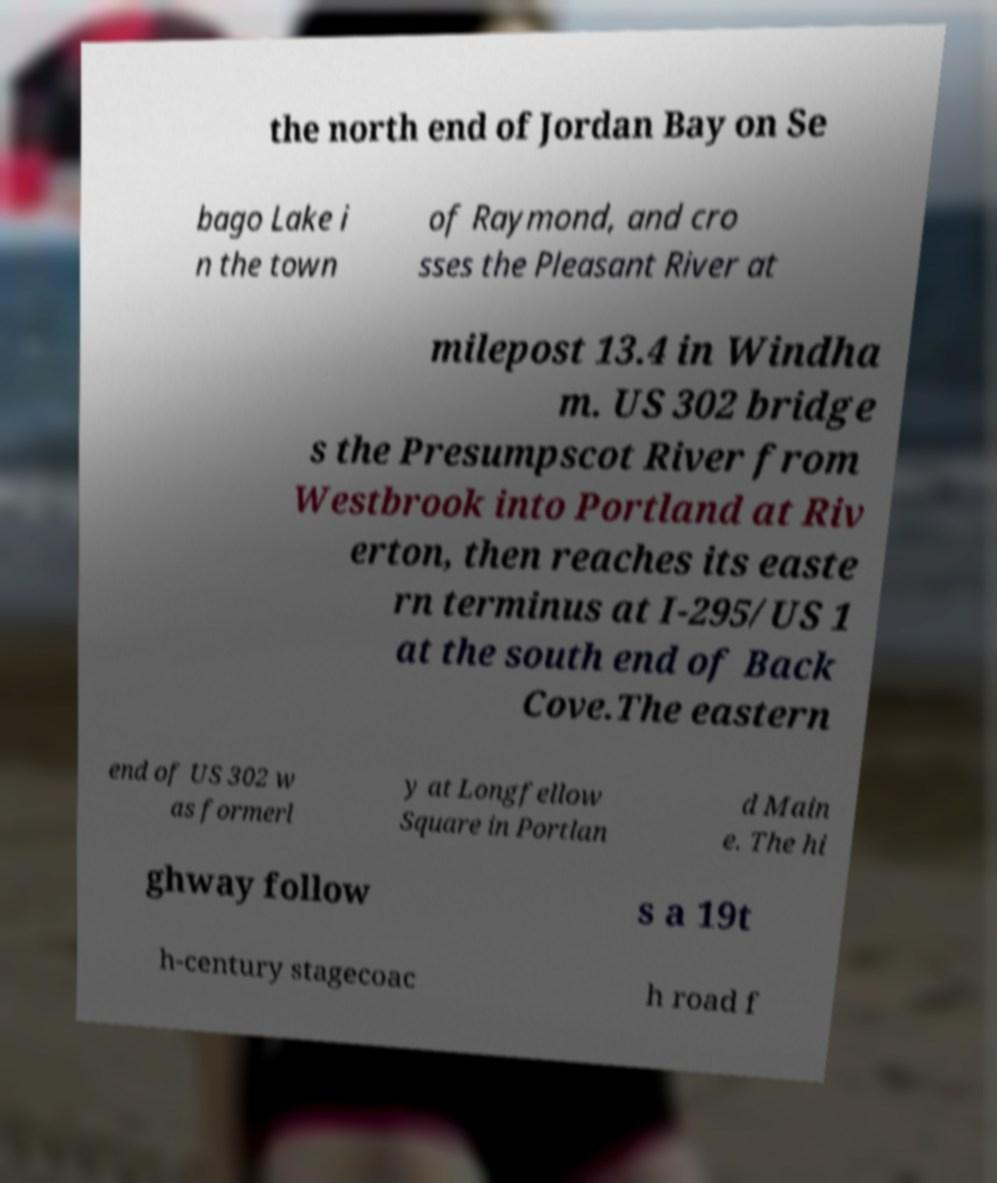There's text embedded in this image that I need extracted. Can you transcribe it verbatim? the north end of Jordan Bay on Se bago Lake i n the town of Raymond, and cro sses the Pleasant River at milepost 13.4 in Windha m. US 302 bridge s the Presumpscot River from Westbrook into Portland at Riv erton, then reaches its easte rn terminus at I-295/US 1 at the south end of Back Cove.The eastern end of US 302 w as formerl y at Longfellow Square in Portlan d Main e. The hi ghway follow s a 19t h-century stagecoac h road f 